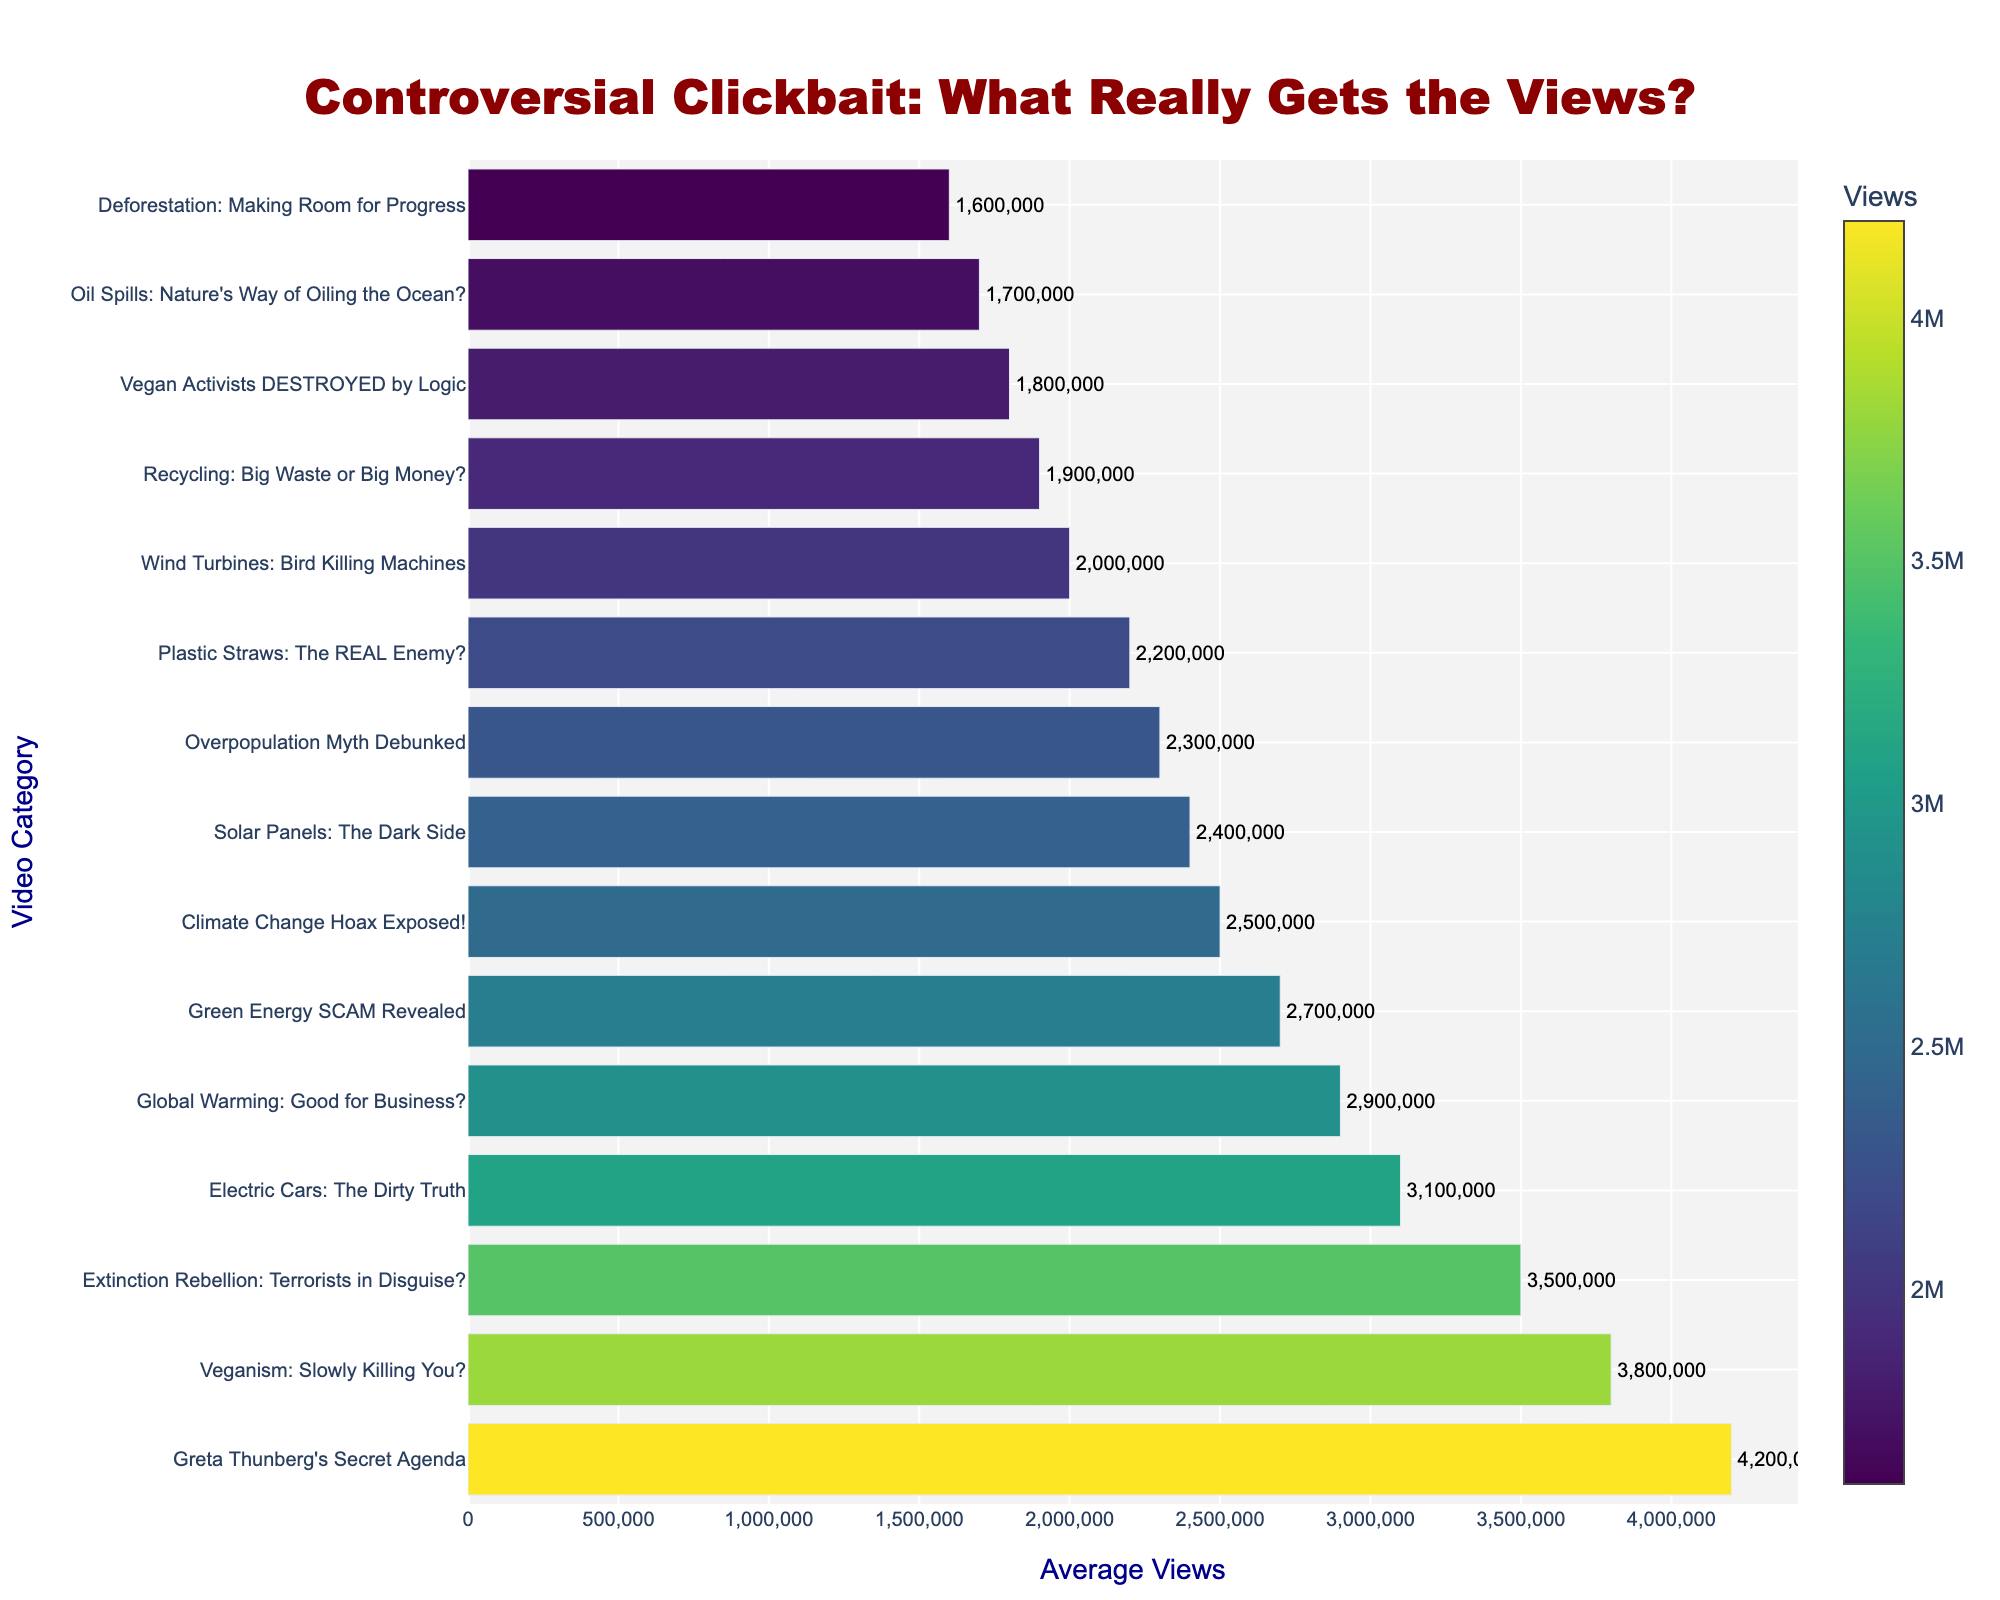What category has the highest average view count? The category "Greta Thunberg's Secret Agenda" has the highest bar in the chart, indicating it has the highest average view count.
Answer: "Greta Thunberg's Secret Agenda" How many categories have an average view count above 2.5 million? The categories "Greta Thunberg's Secret Agenda", "Veganism: Slowly Killing You?", "Extinction Rebellion: Terrorists in Disguise?", and "Electric Cars: The Dirty Truth" have bars extending beyond 2.5 million views.
Answer: 4 Which category has the lowest average view count? The bar for "Deforestation: Making Room for Progress" is the shortest in the chart, indicating it has the lowest average view count.
Answer: "Deforestation: Making Room for Progress" What's the difference in average view counts between "Electric Cars: The Dirty Truth" and "Plastic Straws: The REAL Enemy?" "Electric Cars: The Dirty Truth" has 3,100,000 views, and "Plastic Straws: The REAL Enemy?" has 2,200,000 views. The difference is calculated as 3,100,000 - 2,200,000.
Answer: 900,000 Which two categories are closest in average view count? "Overpopulation Myth Debunked" and "Solar Panels: The Dark Side" have average views of 2,300,000 and 2,400,000 respectively, making them the closest in view counts.
Answer: "Overpopulation Myth Debunked" and "Solar Panels: The Dark Side" What's the average view count for the top three categories? The top three categories are "Greta Thunberg's Secret Agenda" (4,200,000), "Veganism: Slowly Killing You?" (3,800,000), and "Extinction Rebellion: Terrorists in Disguise?" (3,500,000). The average is calculated as (4,200,000 + 3,800,000 + 3,500,000) / 3.
Answer: 3,833,333 Which category has roughly the same average view count as "Recycling: Big Waste or Big Money?" The category "Wind Turbines: Bird Killing Machines" has an average view count close to "Recycling: Big Waste or Big Money?" with 2,000,000 and 1,900,000 views respectively.
Answer: "Wind Turbines: Bird Killing Machines" Which category is fifth in terms of highest average view count? The fifth-highest average view count is for the category "Green Energy SCAM Revealed" with 2,700,000 views.
Answer: "Green Energy SCAM Revealed" 